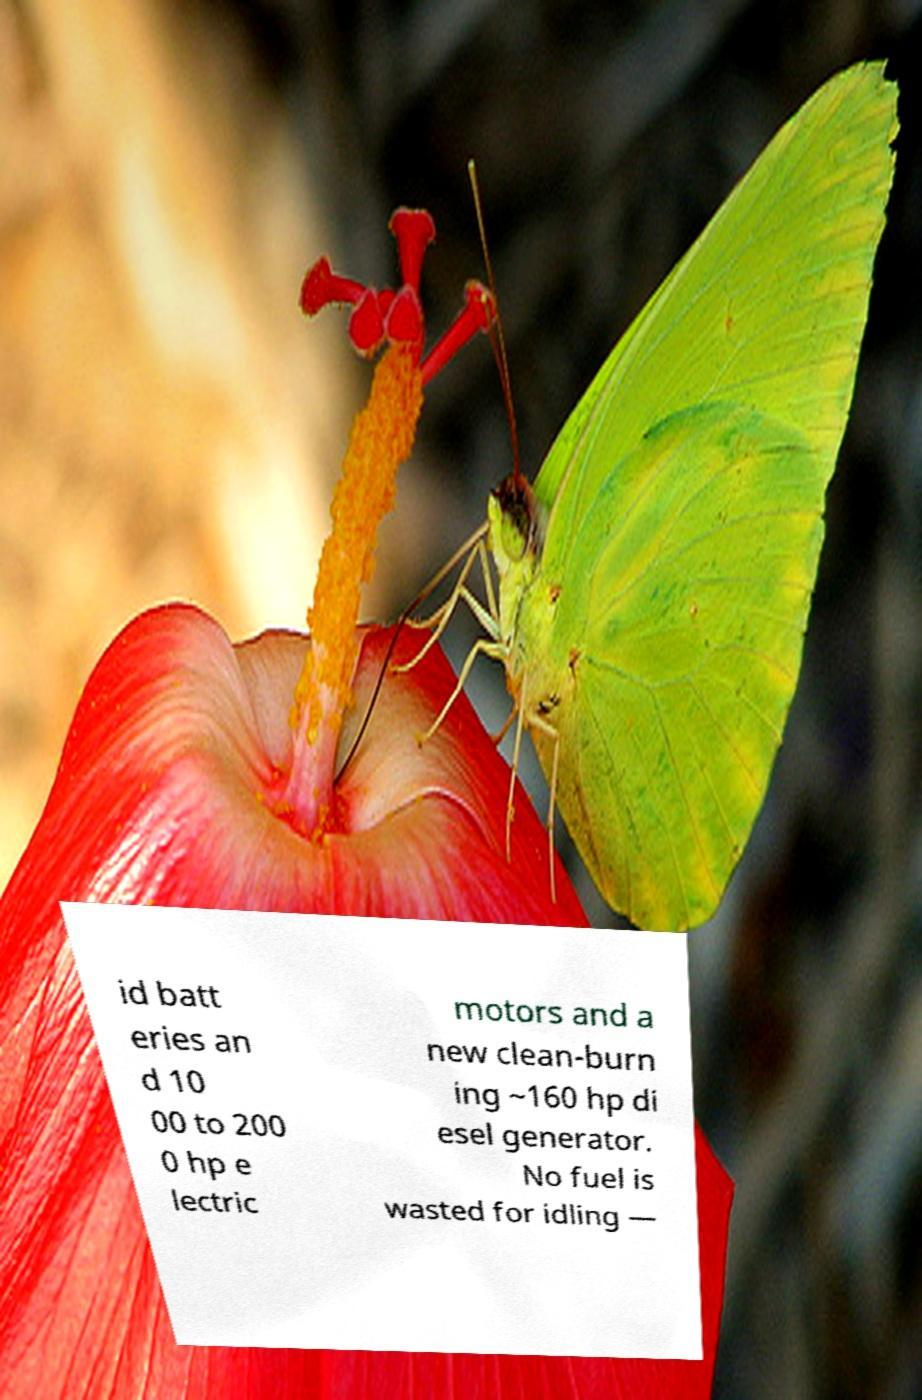For documentation purposes, I need the text within this image transcribed. Could you provide that? id batt eries an d 10 00 to 200 0 hp e lectric motors and a new clean-burn ing ~160 hp di esel generator. No fuel is wasted for idling — 